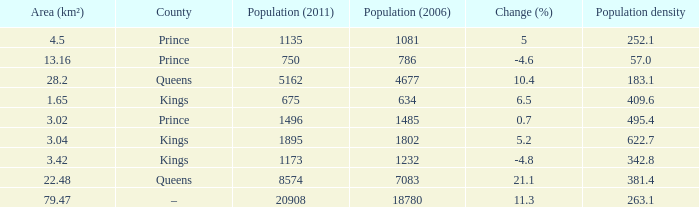What was the Population (2011) when the Population (2006) was less than 7083, and the Population density less than 342.8, and the Change (%) of 5, and an Area (km²) larger than 4.5? 0.0. 